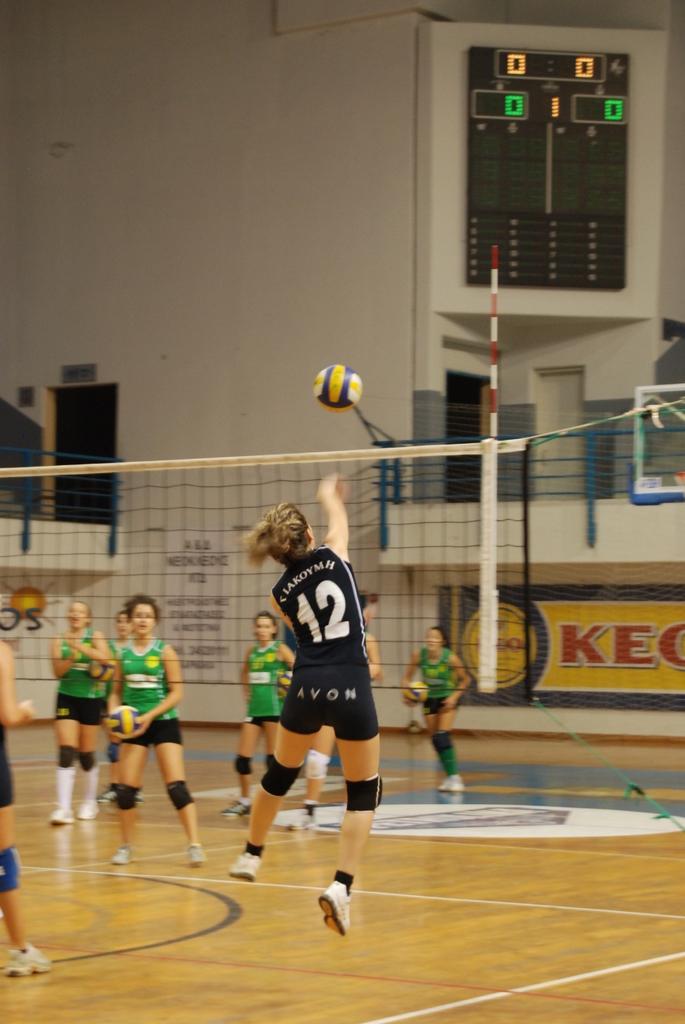In one or two sentences, can you explain what this image depicts? In this image we can see some group of persons who are playing volleyball wearing two different colors of dress one is green and black and at the background of the image there is wall, door, window and at the top of the image there is scoreboard. 